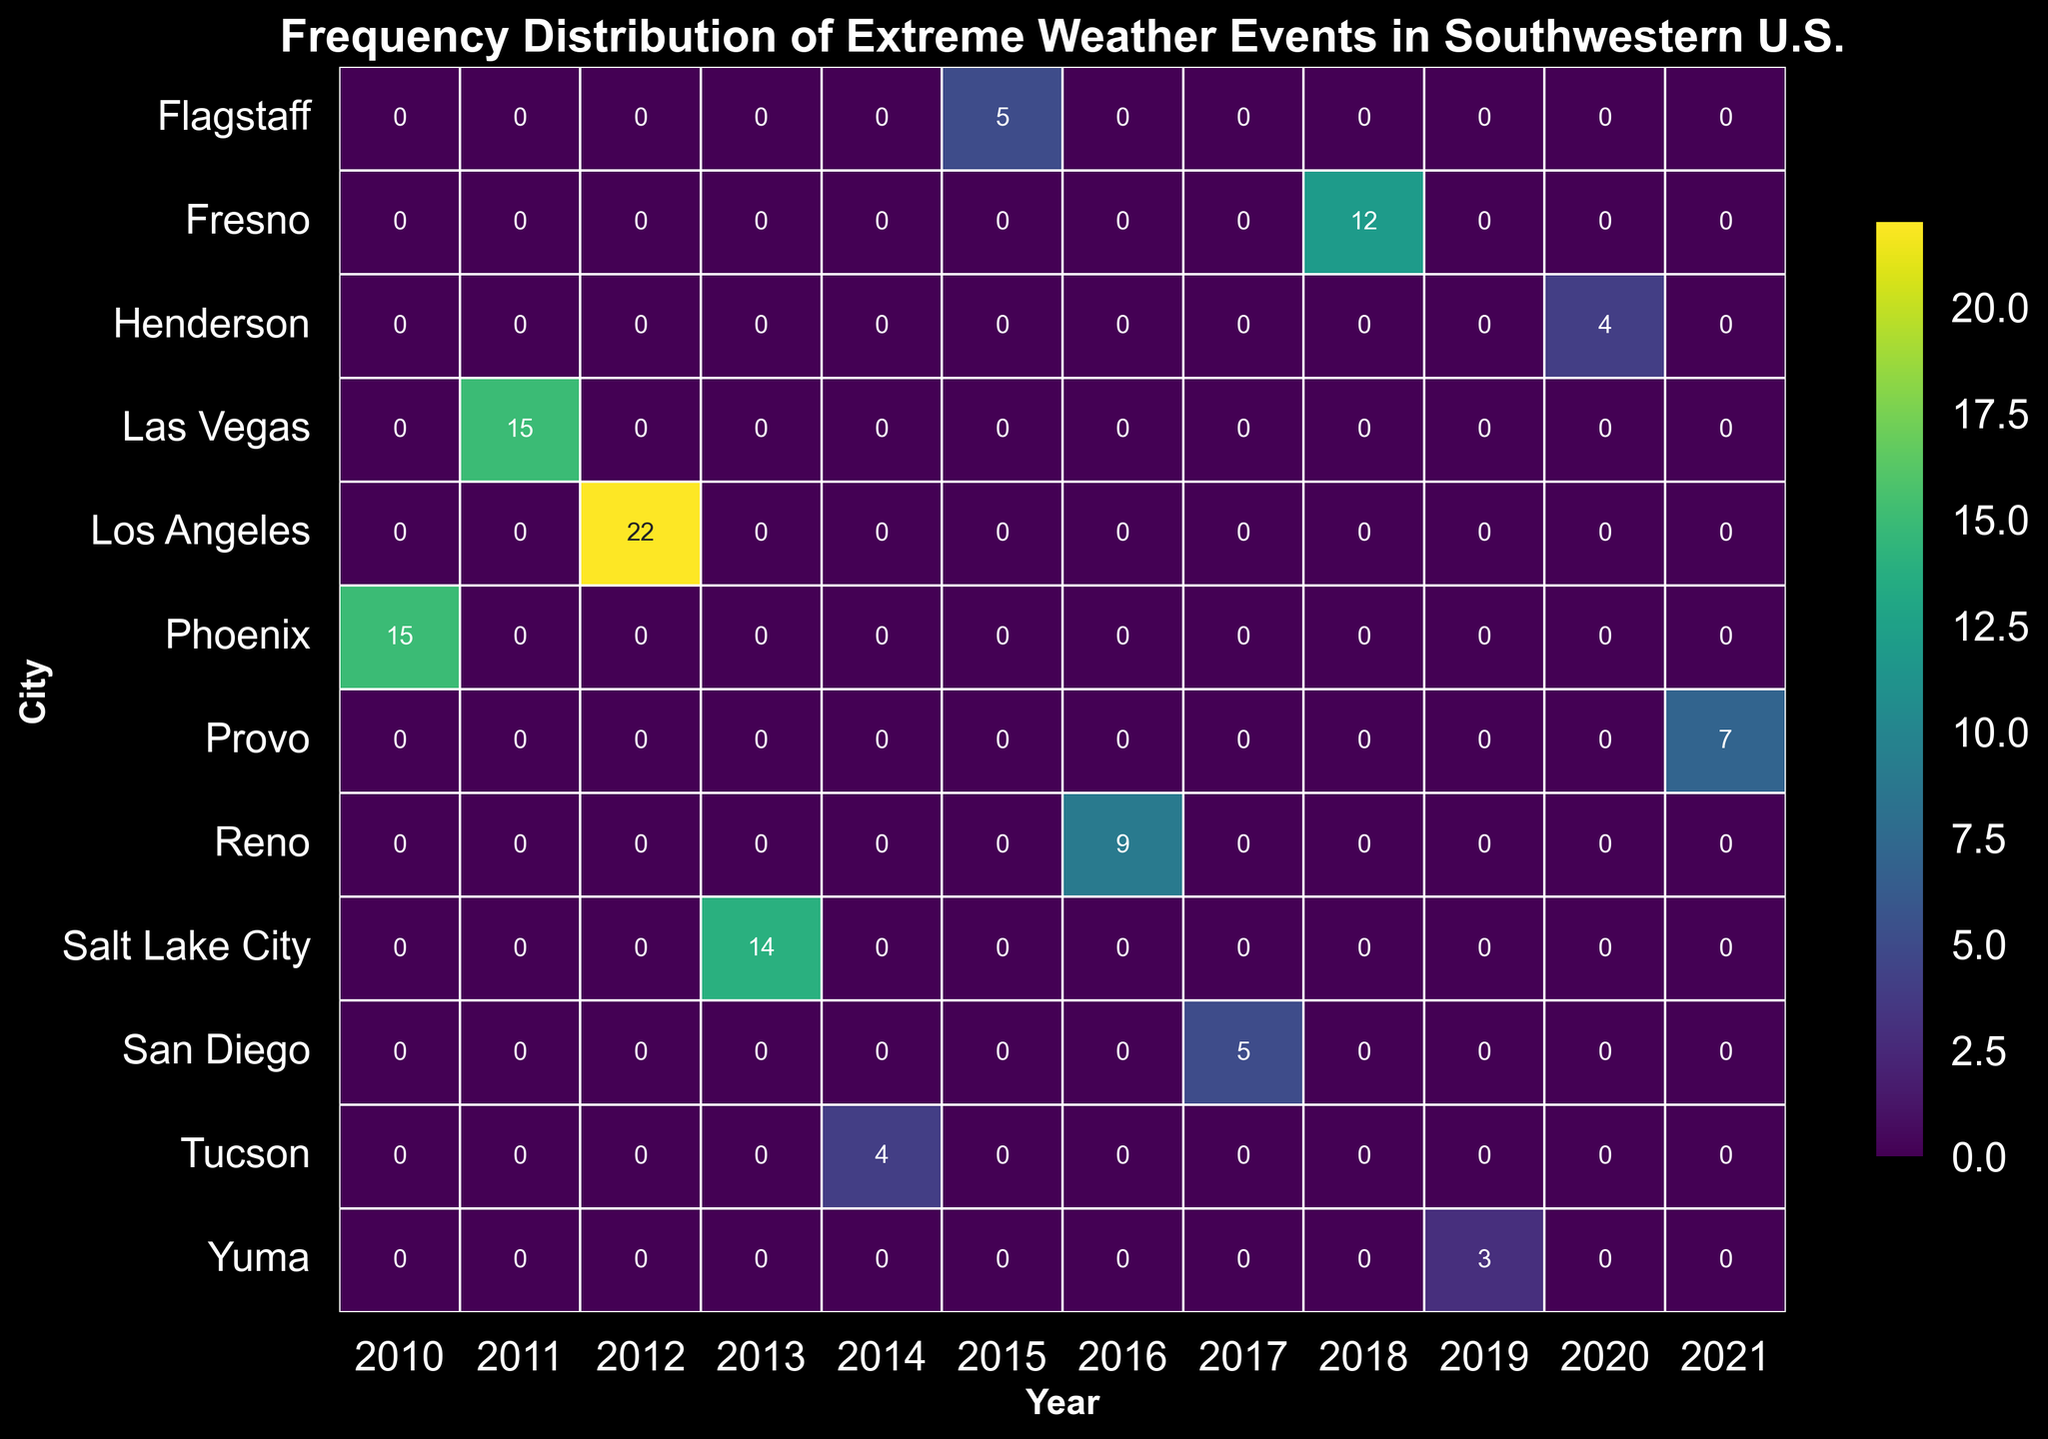What city experienced the highest frequency of extreme weather events in 2011? Look for the cell in 2011 with the highest frequency value. Las Vegas shows a frequency of 12 in 2011, which is the highest for that year.
Answer: Las Vegas Which year did Los Angeles experience the highest frequency of extreme weather events? Check the values for Los Angeles across all years and find the highest value. The highest frequency for Los Angeles is 15 in 2012.
Answer: 2012 Between Phoenix and Tucson, which city had the higher frequency of extreme weather events in their respective months? Compare the frequency of extreme weather events in Phoenix and Tucson from the corresponding months in the data. Phoenix had 10 events in July 2010, while Tucson had 4 events in June 2014.
Answer: Phoenix What is the total frequency of heatwaves across all years and cities? Sum up all the frequencies of heatwaves from the heatmap. These frequencies are 10, 12, 7, 8, 9, 5, and 4, totaling 55.
Answer: 55 In which year did Utah experience a flood? Locate the occurrence of the flood in Utah within the heatmap matrix. The flood in Utah was recorded in 2013.
Answer: 2013 Which city experienced both a heatwave and a dust storm, and in which years? Identify the city with recorded events for both heatwaves and dust storms and note the corresponding years. Las Vegas experienced a heatwave in 2011 and a dust storm in the same year.
Answer: Las Vegas, 2011 How many times did San Diego report extreme weather events from 2015 to 2020? Check the frequencies for San Diego between 2015 and 2020 and sum them up. San Diego shows only one recorded event: 5 in 2017.
Answer: 5 Compare the frequency of extreme weather events in Salt Lake City in 2013 and 2014. Which year had more events? Look at the frequencies for Salt Lake City in 2013 and 2014 and compare them. 2013 shows frequencies of 6 and 8, while there is no recorded event in 2014 in Salt Lake City. Hence, 2013 had more events.
Answer: 2013 What is the average frequency of extreme weather events in Las Vegas from 2010 to 2020? Sum the frequencies of extreme weather events for Las Vegas from 2010 to 2020 and divide by the number of unique years recorded. Las Vegas had events in 2011 and 2020 with frequencies of 12 and 4 respectively, averaging (12 + 4) / 2 = 8.
Answer: 8 Which city experienced the first recorded drought event and in which year? Identify the city and year corresponding to the first recorded drought event. Los Angeles had a drought event first in 2012.
Answer: Los Angeles, 2012 